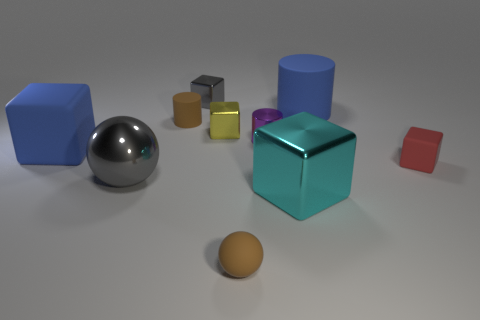Subtract all gray cubes. How many cubes are left? 4 Subtract all cyan cubes. How many cubes are left? 4 Subtract all green blocks. Subtract all gray spheres. How many blocks are left? 5 Subtract all cylinders. How many objects are left? 7 Subtract 1 yellow cubes. How many objects are left? 9 Subtract all tiny red matte cubes. Subtract all brown rubber spheres. How many objects are left? 8 Add 6 large matte things. How many large matte things are left? 8 Add 1 tiny purple objects. How many tiny purple objects exist? 2 